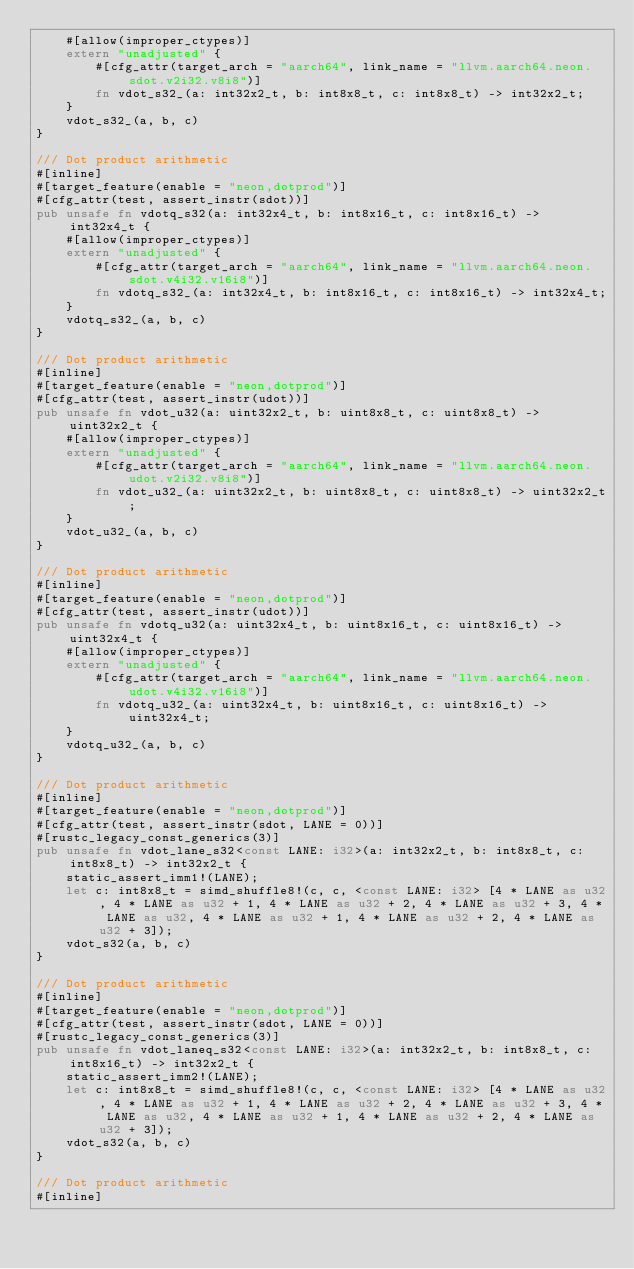Convert code to text. <code><loc_0><loc_0><loc_500><loc_500><_Rust_>    #[allow(improper_ctypes)]
    extern "unadjusted" {
        #[cfg_attr(target_arch = "aarch64", link_name = "llvm.aarch64.neon.sdot.v2i32.v8i8")]
        fn vdot_s32_(a: int32x2_t, b: int8x8_t, c: int8x8_t) -> int32x2_t;
    }
    vdot_s32_(a, b, c)
}

/// Dot product arithmetic
#[inline]
#[target_feature(enable = "neon,dotprod")]
#[cfg_attr(test, assert_instr(sdot))]
pub unsafe fn vdotq_s32(a: int32x4_t, b: int8x16_t, c: int8x16_t) -> int32x4_t {
    #[allow(improper_ctypes)]
    extern "unadjusted" {
        #[cfg_attr(target_arch = "aarch64", link_name = "llvm.aarch64.neon.sdot.v4i32.v16i8")]
        fn vdotq_s32_(a: int32x4_t, b: int8x16_t, c: int8x16_t) -> int32x4_t;
    }
    vdotq_s32_(a, b, c)
}

/// Dot product arithmetic
#[inline]
#[target_feature(enable = "neon,dotprod")]
#[cfg_attr(test, assert_instr(udot))]
pub unsafe fn vdot_u32(a: uint32x2_t, b: uint8x8_t, c: uint8x8_t) -> uint32x2_t {
    #[allow(improper_ctypes)]
    extern "unadjusted" {
        #[cfg_attr(target_arch = "aarch64", link_name = "llvm.aarch64.neon.udot.v2i32.v8i8")]
        fn vdot_u32_(a: uint32x2_t, b: uint8x8_t, c: uint8x8_t) -> uint32x2_t;
    }
    vdot_u32_(a, b, c)
}

/// Dot product arithmetic
#[inline]
#[target_feature(enable = "neon,dotprod")]
#[cfg_attr(test, assert_instr(udot))]
pub unsafe fn vdotq_u32(a: uint32x4_t, b: uint8x16_t, c: uint8x16_t) -> uint32x4_t {
    #[allow(improper_ctypes)]
    extern "unadjusted" {
        #[cfg_attr(target_arch = "aarch64", link_name = "llvm.aarch64.neon.udot.v4i32.v16i8")]
        fn vdotq_u32_(a: uint32x4_t, b: uint8x16_t, c: uint8x16_t) -> uint32x4_t;
    }
    vdotq_u32_(a, b, c)
}

/// Dot product arithmetic
#[inline]
#[target_feature(enable = "neon,dotprod")]
#[cfg_attr(test, assert_instr(sdot, LANE = 0))]
#[rustc_legacy_const_generics(3)]
pub unsafe fn vdot_lane_s32<const LANE: i32>(a: int32x2_t, b: int8x8_t, c: int8x8_t) -> int32x2_t {
    static_assert_imm1!(LANE);
    let c: int8x8_t = simd_shuffle8!(c, c, <const LANE: i32> [4 * LANE as u32, 4 * LANE as u32 + 1, 4 * LANE as u32 + 2, 4 * LANE as u32 + 3, 4 * LANE as u32, 4 * LANE as u32 + 1, 4 * LANE as u32 + 2, 4 * LANE as u32 + 3]);
    vdot_s32(a, b, c)
}

/// Dot product arithmetic
#[inline]
#[target_feature(enable = "neon,dotprod")]
#[cfg_attr(test, assert_instr(sdot, LANE = 0))]
#[rustc_legacy_const_generics(3)]
pub unsafe fn vdot_laneq_s32<const LANE: i32>(a: int32x2_t, b: int8x8_t, c: int8x16_t) -> int32x2_t {
    static_assert_imm2!(LANE);
    let c: int8x8_t = simd_shuffle8!(c, c, <const LANE: i32> [4 * LANE as u32, 4 * LANE as u32 + 1, 4 * LANE as u32 + 2, 4 * LANE as u32 + 3, 4 * LANE as u32, 4 * LANE as u32 + 1, 4 * LANE as u32 + 2, 4 * LANE as u32 + 3]);
    vdot_s32(a, b, c)
}

/// Dot product arithmetic
#[inline]</code> 